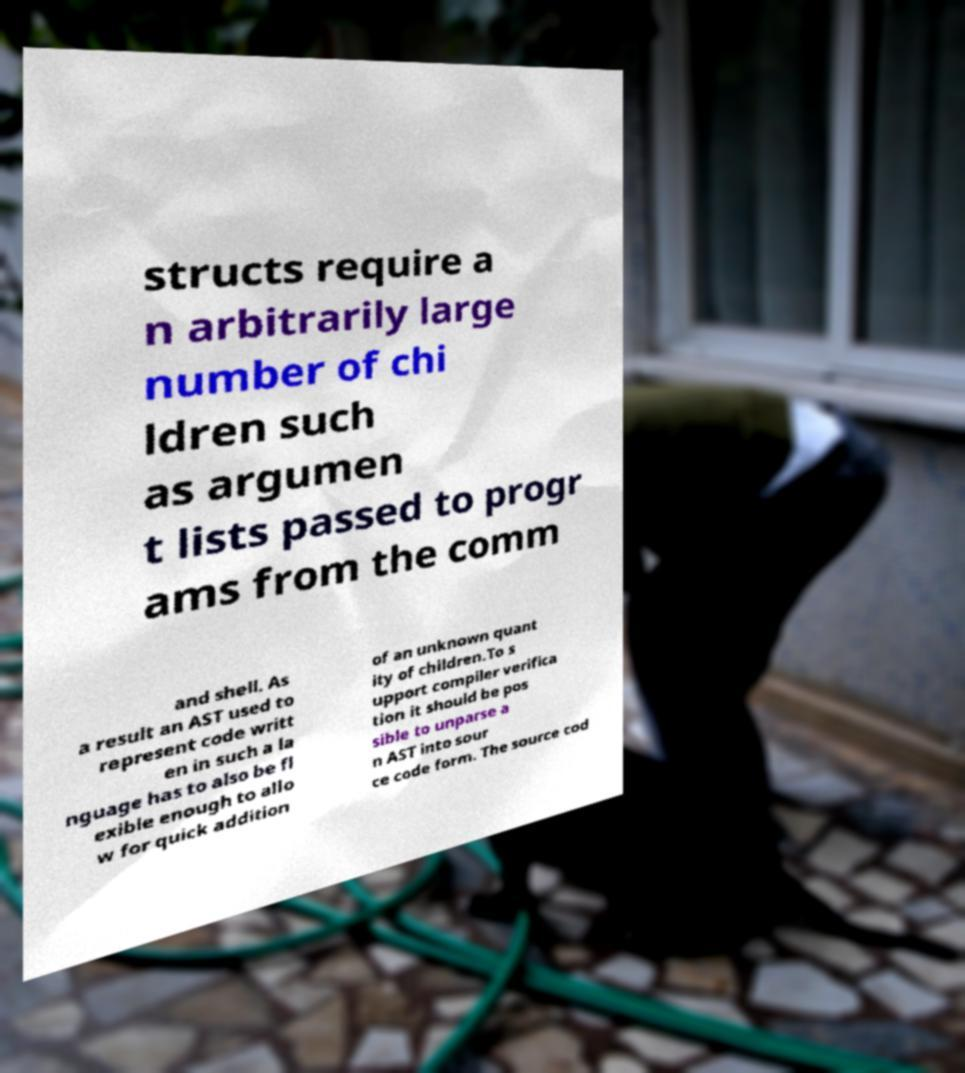Please identify and transcribe the text found in this image. structs require a n arbitrarily large number of chi ldren such as argumen t lists passed to progr ams from the comm and shell. As a result an AST used to represent code writt en in such a la nguage has to also be fl exible enough to allo w for quick addition of an unknown quant ity of children.To s upport compiler verifica tion it should be pos sible to unparse a n AST into sour ce code form. The source cod 